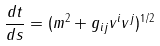Convert formula to latex. <formula><loc_0><loc_0><loc_500><loc_500>\frac { d t } { d s } = ( m ^ { 2 } + g _ { i j } v ^ { i } v ^ { j } ) ^ { 1 / 2 }</formula> 